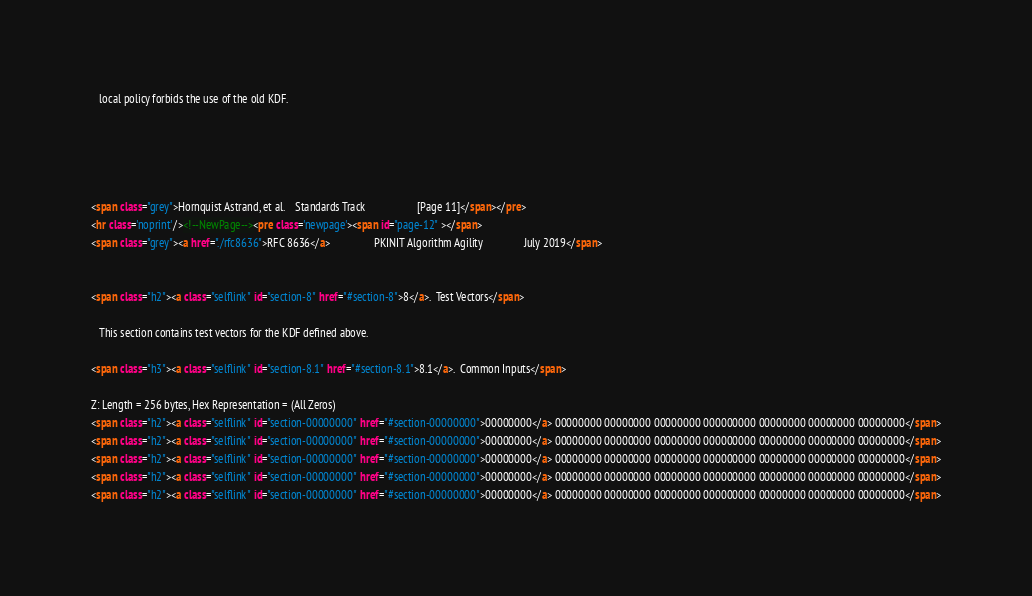<code> <loc_0><loc_0><loc_500><loc_500><_HTML_>   local policy forbids the use of the old KDF.





<span class="grey">Hornquist Astrand, et al.    Standards Track                   [Page 11]</span></pre>
<hr class='noprint'/><!--NewPage--><pre class='newpage'><span id="page-12" ></span>
<span class="grey"><a href="./rfc8636">RFC 8636</a>                PKINIT Algorithm Agility               July 2019</span>


<span class="h2"><a class="selflink" id="section-8" href="#section-8">8</a>.  Test Vectors</span>

   This section contains test vectors for the KDF defined above.

<span class="h3"><a class="selflink" id="section-8.1" href="#section-8.1">8.1</a>.  Common Inputs</span>

Z: Length = 256 bytes, Hex Representation = (All Zeros)
<span class="h2"><a class="selflink" id="section-00000000" href="#section-00000000">00000000</a> 00000000 00000000 00000000 000000000 00000000 00000000 00000000</span>
<span class="h2"><a class="selflink" id="section-00000000" href="#section-00000000">00000000</a> 00000000 00000000 00000000 000000000 00000000 00000000 00000000</span>
<span class="h2"><a class="selflink" id="section-00000000" href="#section-00000000">00000000</a> 00000000 00000000 00000000 000000000 00000000 00000000 00000000</span>
<span class="h2"><a class="selflink" id="section-00000000" href="#section-00000000">00000000</a> 00000000 00000000 00000000 000000000 00000000 00000000 00000000</span>
<span class="h2"><a class="selflink" id="section-00000000" href="#section-00000000">00000000</a> 00000000 00000000 00000000 000000000 00000000 00000000 00000000</span></code> 